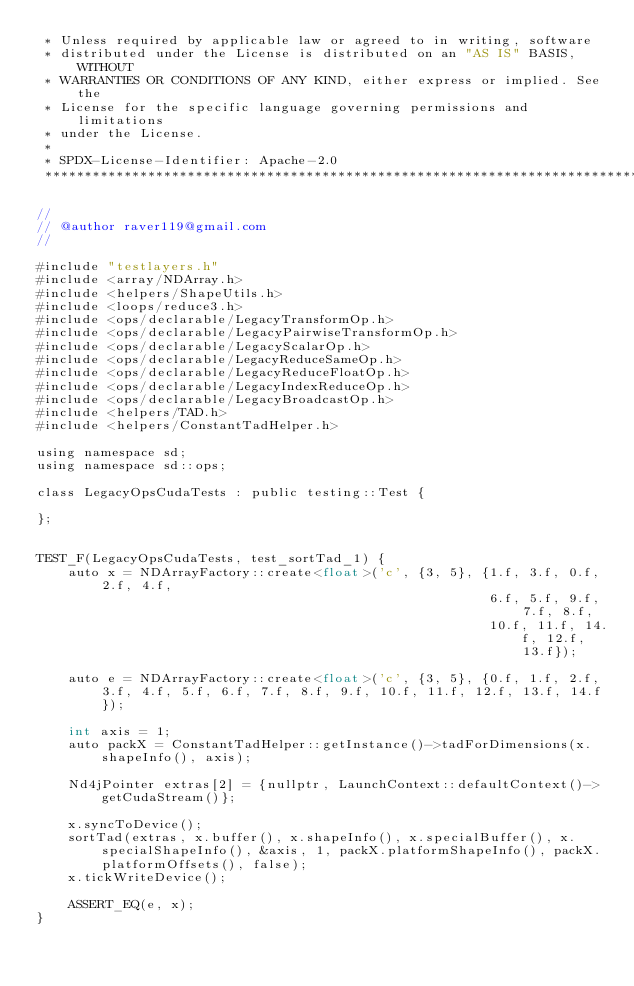<code> <loc_0><loc_0><loc_500><loc_500><_Cuda_> * Unless required by applicable law or agreed to in writing, software
 * distributed under the License is distributed on an "AS IS" BASIS, WITHOUT
 * WARRANTIES OR CONDITIONS OF ANY KIND, either express or implied. See the
 * License for the specific language governing permissions and limitations
 * under the License.
 *
 * SPDX-License-Identifier: Apache-2.0
 ******************************************************************************/

//
// @author raver119@gmail.com
//

#include "testlayers.h"
#include <array/NDArray.h>
#include <helpers/ShapeUtils.h>
#include <loops/reduce3.h>
#include <ops/declarable/LegacyTransformOp.h>
#include <ops/declarable/LegacyPairwiseTransformOp.h>
#include <ops/declarable/LegacyScalarOp.h>
#include <ops/declarable/LegacyReduceSameOp.h>
#include <ops/declarable/LegacyReduceFloatOp.h>
#include <ops/declarable/LegacyIndexReduceOp.h>
#include <ops/declarable/LegacyBroadcastOp.h>
#include <helpers/TAD.h>
#include <helpers/ConstantTadHelper.h>

using namespace sd;
using namespace sd::ops;

class LegacyOpsCudaTests : public testing::Test {

};


TEST_F(LegacyOpsCudaTests, test_sortTad_1) {
    auto x = NDArrayFactory::create<float>('c', {3, 5}, {1.f, 3.f, 0.f, 2.f, 4.f,
                                                         6.f, 5.f, 9.f, 7.f, 8.f,
                                                         10.f, 11.f, 14.f, 12.f, 13.f});

    auto e = NDArrayFactory::create<float>('c', {3, 5}, {0.f, 1.f, 2.f, 3.f, 4.f, 5.f, 6.f, 7.f, 8.f, 9.f, 10.f, 11.f, 12.f, 13.f, 14.f});

    int axis = 1;
    auto packX = ConstantTadHelper::getInstance()->tadForDimensions(x.shapeInfo(), axis);

    Nd4jPointer extras[2] = {nullptr, LaunchContext::defaultContext()->getCudaStream()};

    x.syncToDevice();
    sortTad(extras, x.buffer(), x.shapeInfo(), x.specialBuffer(), x.specialShapeInfo(), &axis, 1, packX.platformShapeInfo(), packX.platformOffsets(), false);
    x.tickWriteDevice();

    ASSERT_EQ(e, x);
}
</code> 